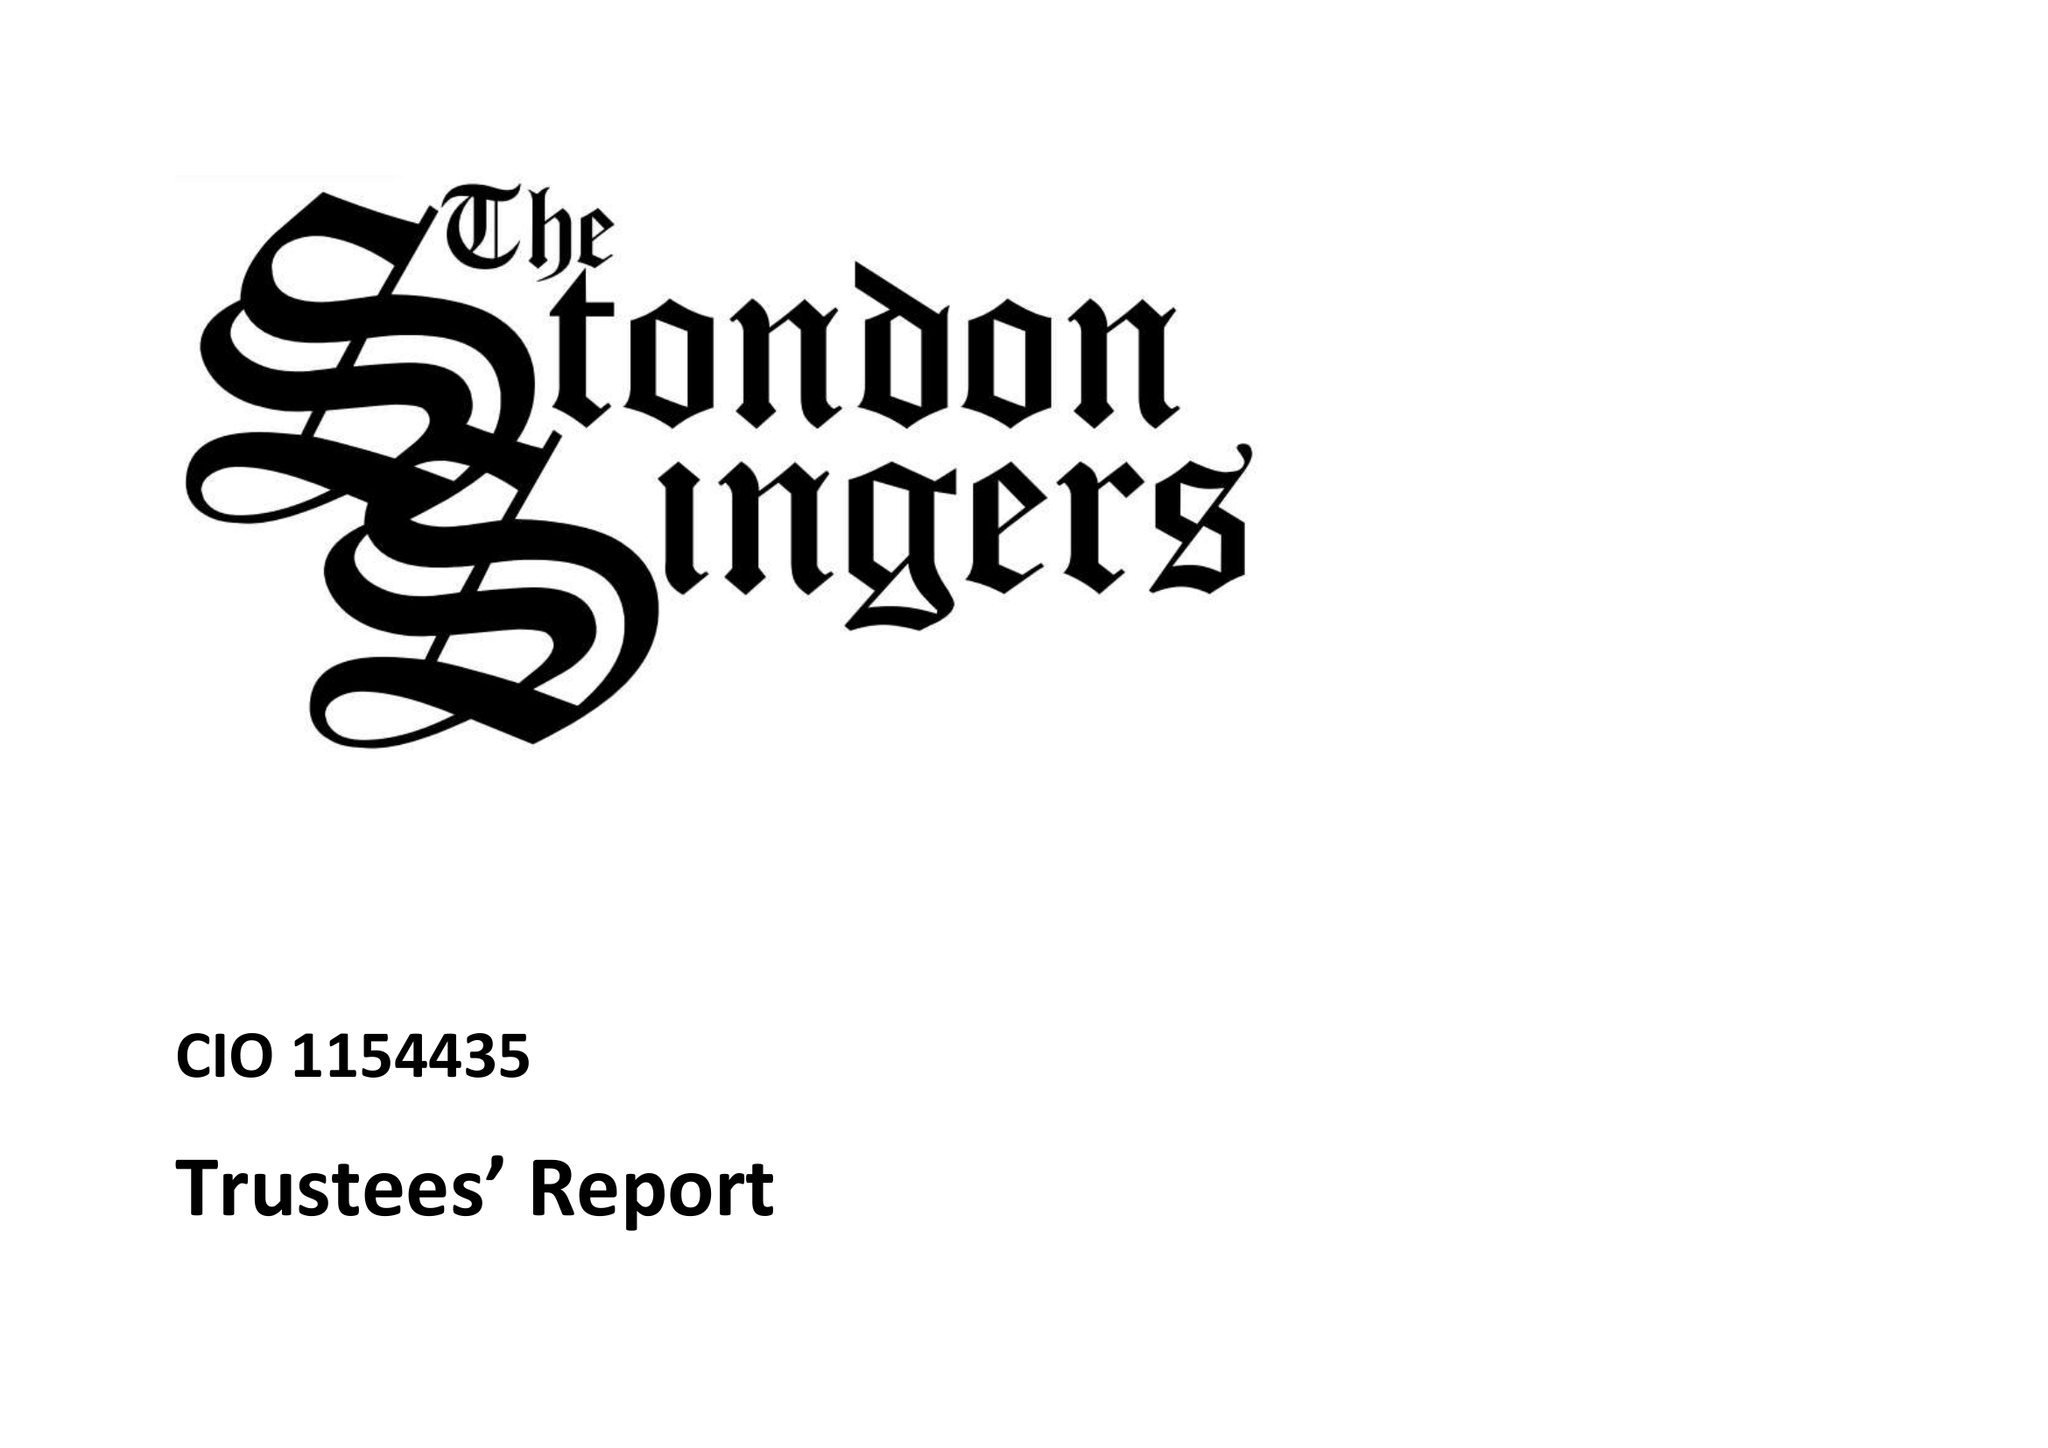What is the value for the report_date?
Answer the question using a single word or phrase. 2014-12-31 